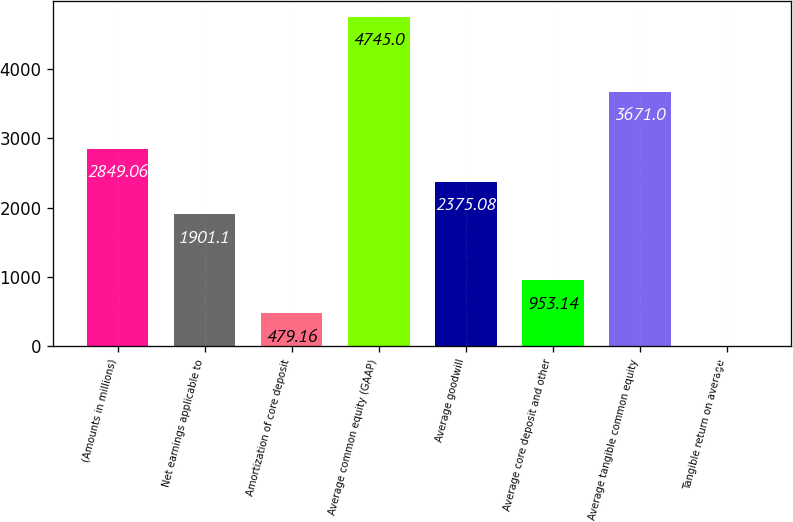<chart> <loc_0><loc_0><loc_500><loc_500><bar_chart><fcel>(Amounts in millions)<fcel>Net earnings applicable to<fcel>Amortization of core deposit<fcel>Average common equity (GAAP)<fcel>Average goodwill<fcel>Average core deposit and other<fcel>Average tangible common equity<fcel>Tangible return on average<nl><fcel>2849.06<fcel>1901.1<fcel>479.16<fcel>4745<fcel>2375.08<fcel>953.14<fcel>3671<fcel>5.18<nl></chart> 